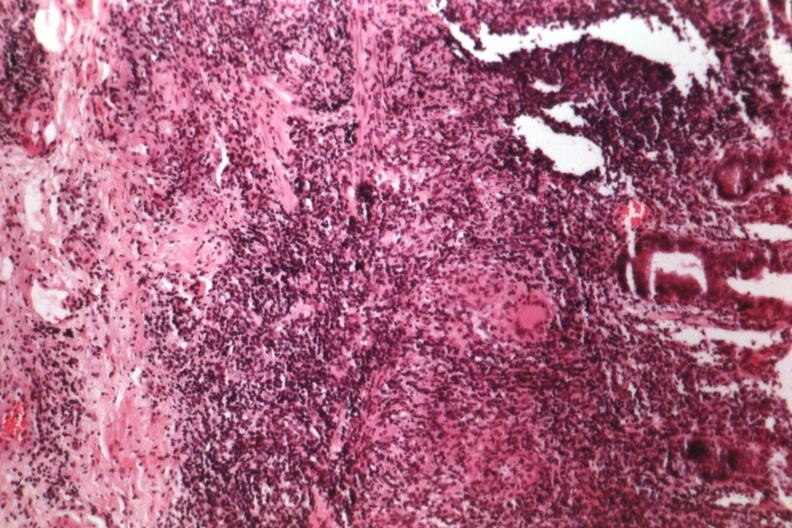s gastrointestinal present?
Answer the question using a single word or phrase. Yes 